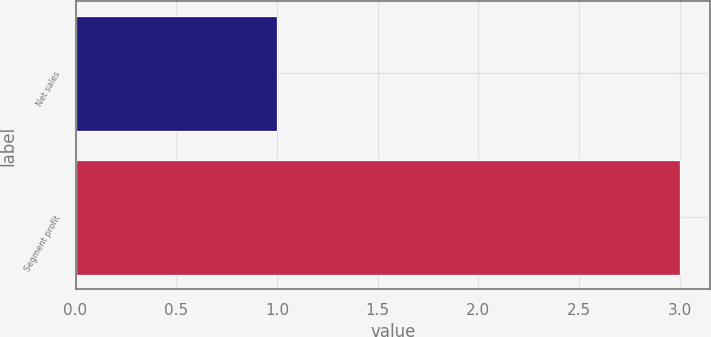<chart> <loc_0><loc_0><loc_500><loc_500><bar_chart><fcel>Net sales<fcel>Segment profit<nl><fcel>1<fcel>3<nl></chart> 